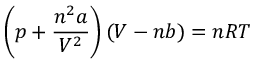Convert formula to latex. <formula><loc_0><loc_0><loc_500><loc_500>\left ( p + { \frac { n ^ { 2 } a } { V ^ { 2 } } } \right ) \left ( V - n b \right ) = n R T</formula> 